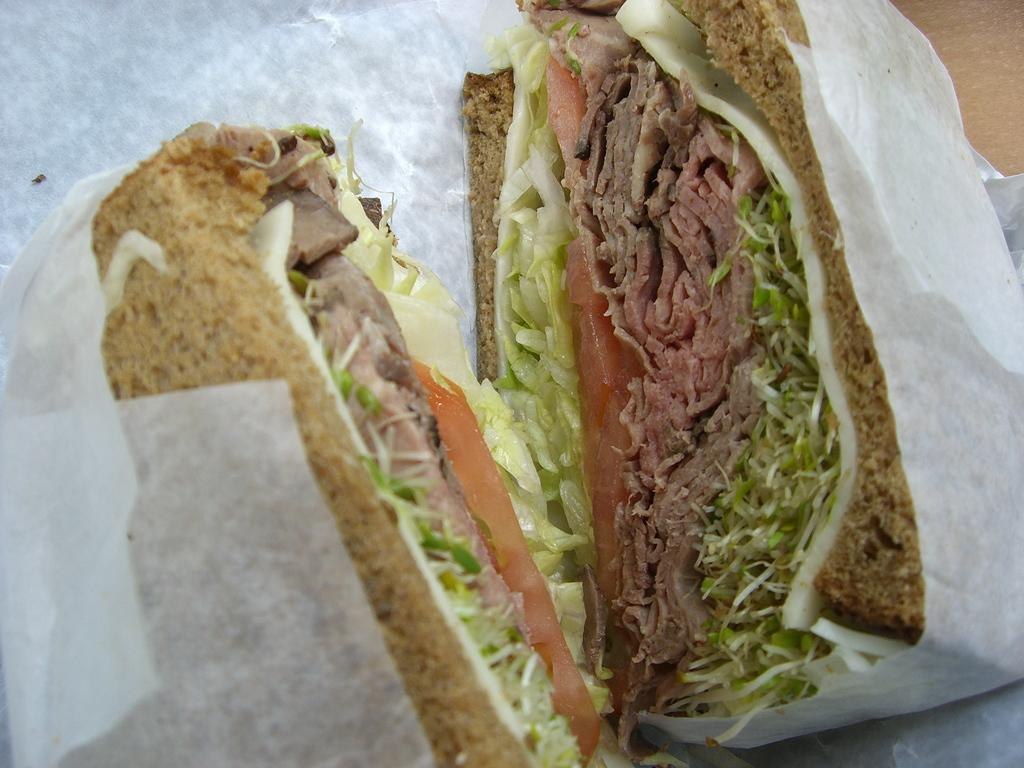What is the main subject of the image? The main subject of the image is a food item. How is the food item packaged? The food item is packed with a white color paper. What type of bird can be seen ringing a bell in the image? There is no bird or bell present in the image; it only features a food item packed with white color paper. 